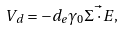Convert formula to latex. <formula><loc_0><loc_0><loc_500><loc_500>V _ { d } = - d _ { e } \gamma _ { 0 } \vec { \Sigma \cdot E } ,</formula> 